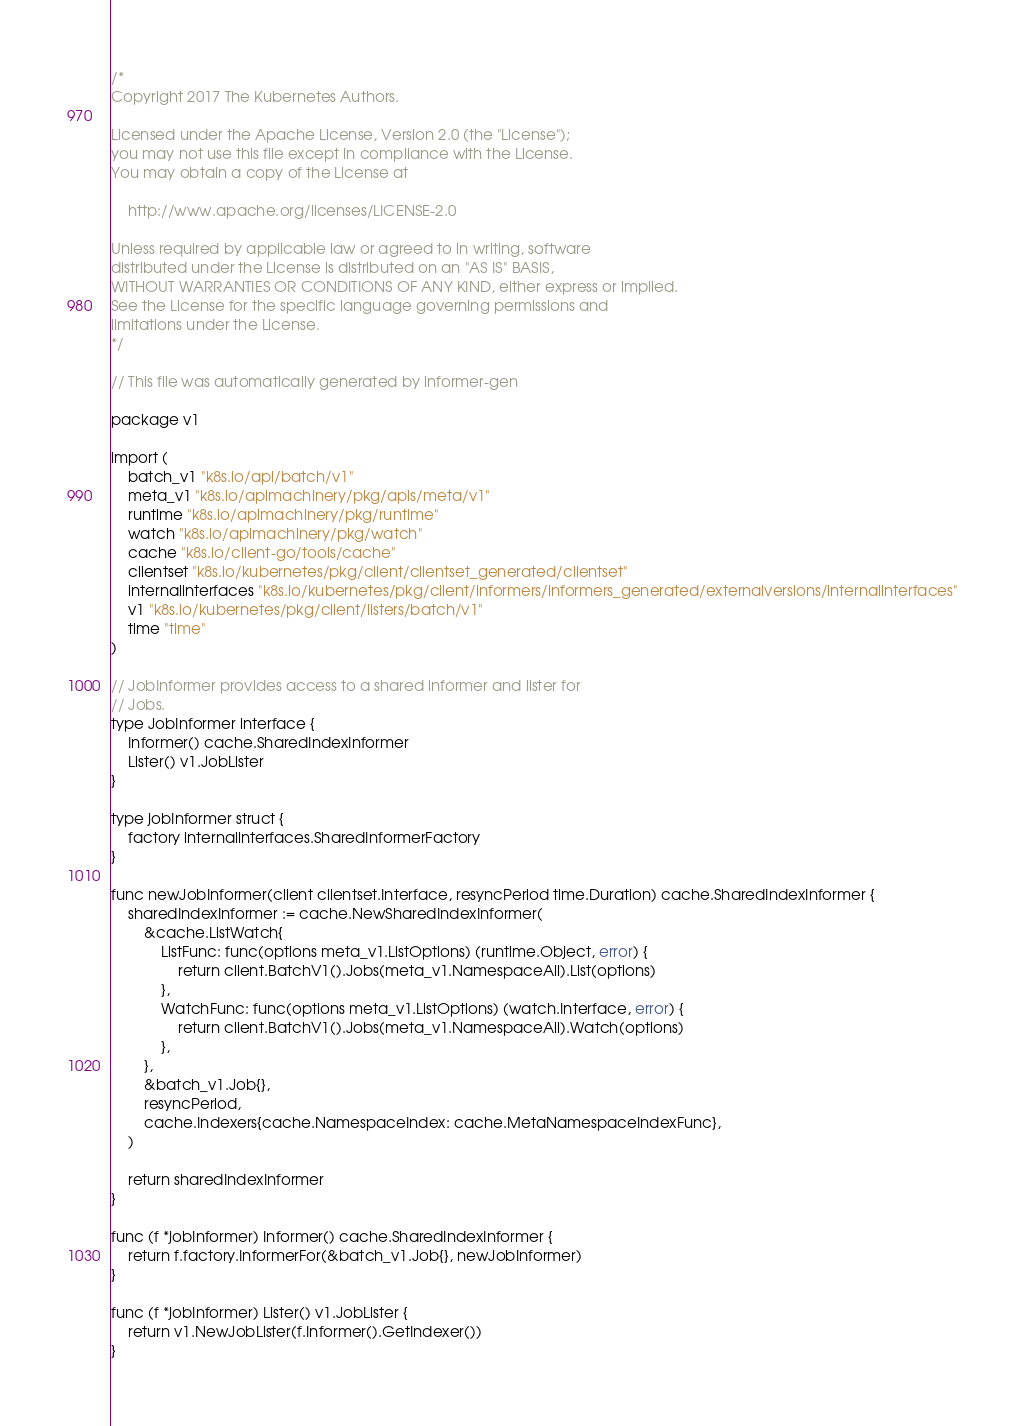Convert code to text. <code><loc_0><loc_0><loc_500><loc_500><_Go_>/*
Copyright 2017 The Kubernetes Authors.

Licensed under the Apache License, Version 2.0 (the "License");
you may not use this file except in compliance with the License.
You may obtain a copy of the License at

    http://www.apache.org/licenses/LICENSE-2.0

Unless required by applicable law or agreed to in writing, software
distributed under the License is distributed on an "AS IS" BASIS,
WITHOUT WARRANTIES OR CONDITIONS OF ANY KIND, either express or implied.
See the License for the specific language governing permissions and
limitations under the License.
*/

// This file was automatically generated by informer-gen

package v1

import (
	batch_v1 "k8s.io/api/batch/v1"
	meta_v1 "k8s.io/apimachinery/pkg/apis/meta/v1"
	runtime "k8s.io/apimachinery/pkg/runtime"
	watch "k8s.io/apimachinery/pkg/watch"
	cache "k8s.io/client-go/tools/cache"
	clientset "k8s.io/kubernetes/pkg/client/clientset_generated/clientset"
	internalinterfaces "k8s.io/kubernetes/pkg/client/informers/informers_generated/externalversions/internalinterfaces"
	v1 "k8s.io/kubernetes/pkg/client/listers/batch/v1"
	time "time"
)

// JobInformer provides access to a shared informer and lister for
// Jobs.
type JobInformer interface {
	Informer() cache.SharedIndexInformer
	Lister() v1.JobLister
}

type jobInformer struct {
	factory internalinterfaces.SharedInformerFactory
}

func newJobInformer(client clientset.Interface, resyncPeriod time.Duration) cache.SharedIndexInformer {
	sharedIndexInformer := cache.NewSharedIndexInformer(
		&cache.ListWatch{
			ListFunc: func(options meta_v1.ListOptions) (runtime.Object, error) {
				return client.BatchV1().Jobs(meta_v1.NamespaceAll).List(options)
			},
			WatchFunc: func(options meta_v1.ListOptions) (watch.Interface, error) {
				return client.BatchV1().Jobs(meta_v1.NamespaceAll).Watch(options)
			},
		},
		&batch_v1.Job{},
		resyncPeriod,
		cache.Indexers{cache.NamespaceIndex: cache.MetaNamespaceIndexFunc},
	)

	return sharedIndexInformer
}

func (f *jobInformer) Informer() cache.SharedIndexInformer {
	return f.factory.InformerFor(&batch_v1.Job{}, newJobInformer)
}

func (f *jobInformer) Lister() v1.JobLister {
	return v1.NewJobLister(f.Informer().GetIndexer())
}
</code> 